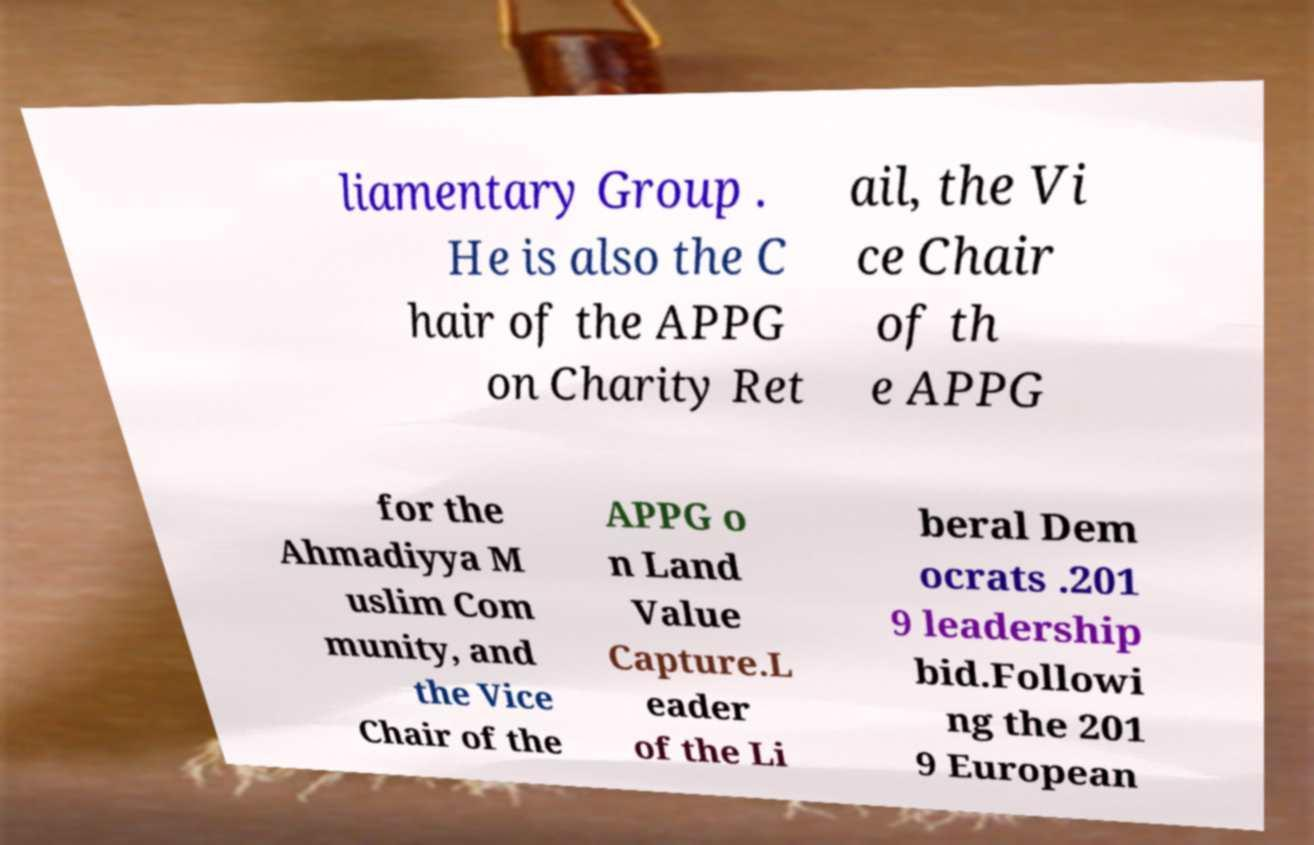Please read and relay the text visible in this image. What does it say? liamentary Group . He is also the C hair of the APPG on Charity Ret ail, the Vi ce Chair of th e APPG for the Ahmadiyya M uslim Com munity, and the Vice Chair of the APPG o n Land Value Capture.L eader of the Li beral Dem ocrats .201 9 leadership bid.Followi ng the 201 9 European 